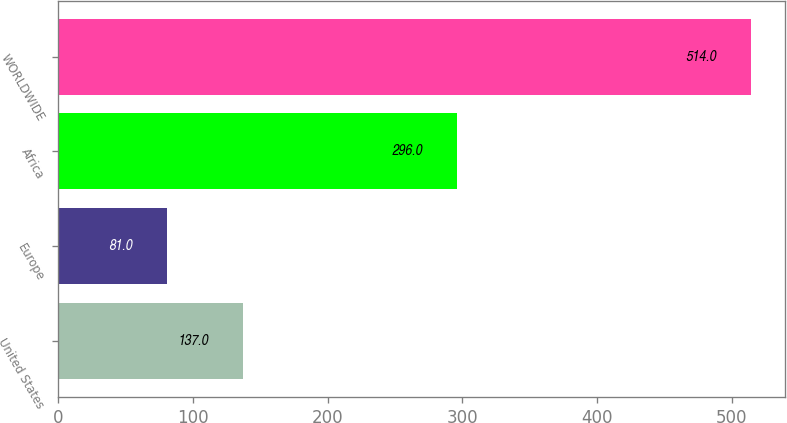Convert chart to OTSL. <chart><loc_0><loc_0><loc_500><loc_500><bar_chart><fcel>United States<fcel>Europe<fcel>Africa<fcel>WORLDWIDE<nl><fcel>137<fcel>81<fcel>296<fcel>514<nl></chart> 